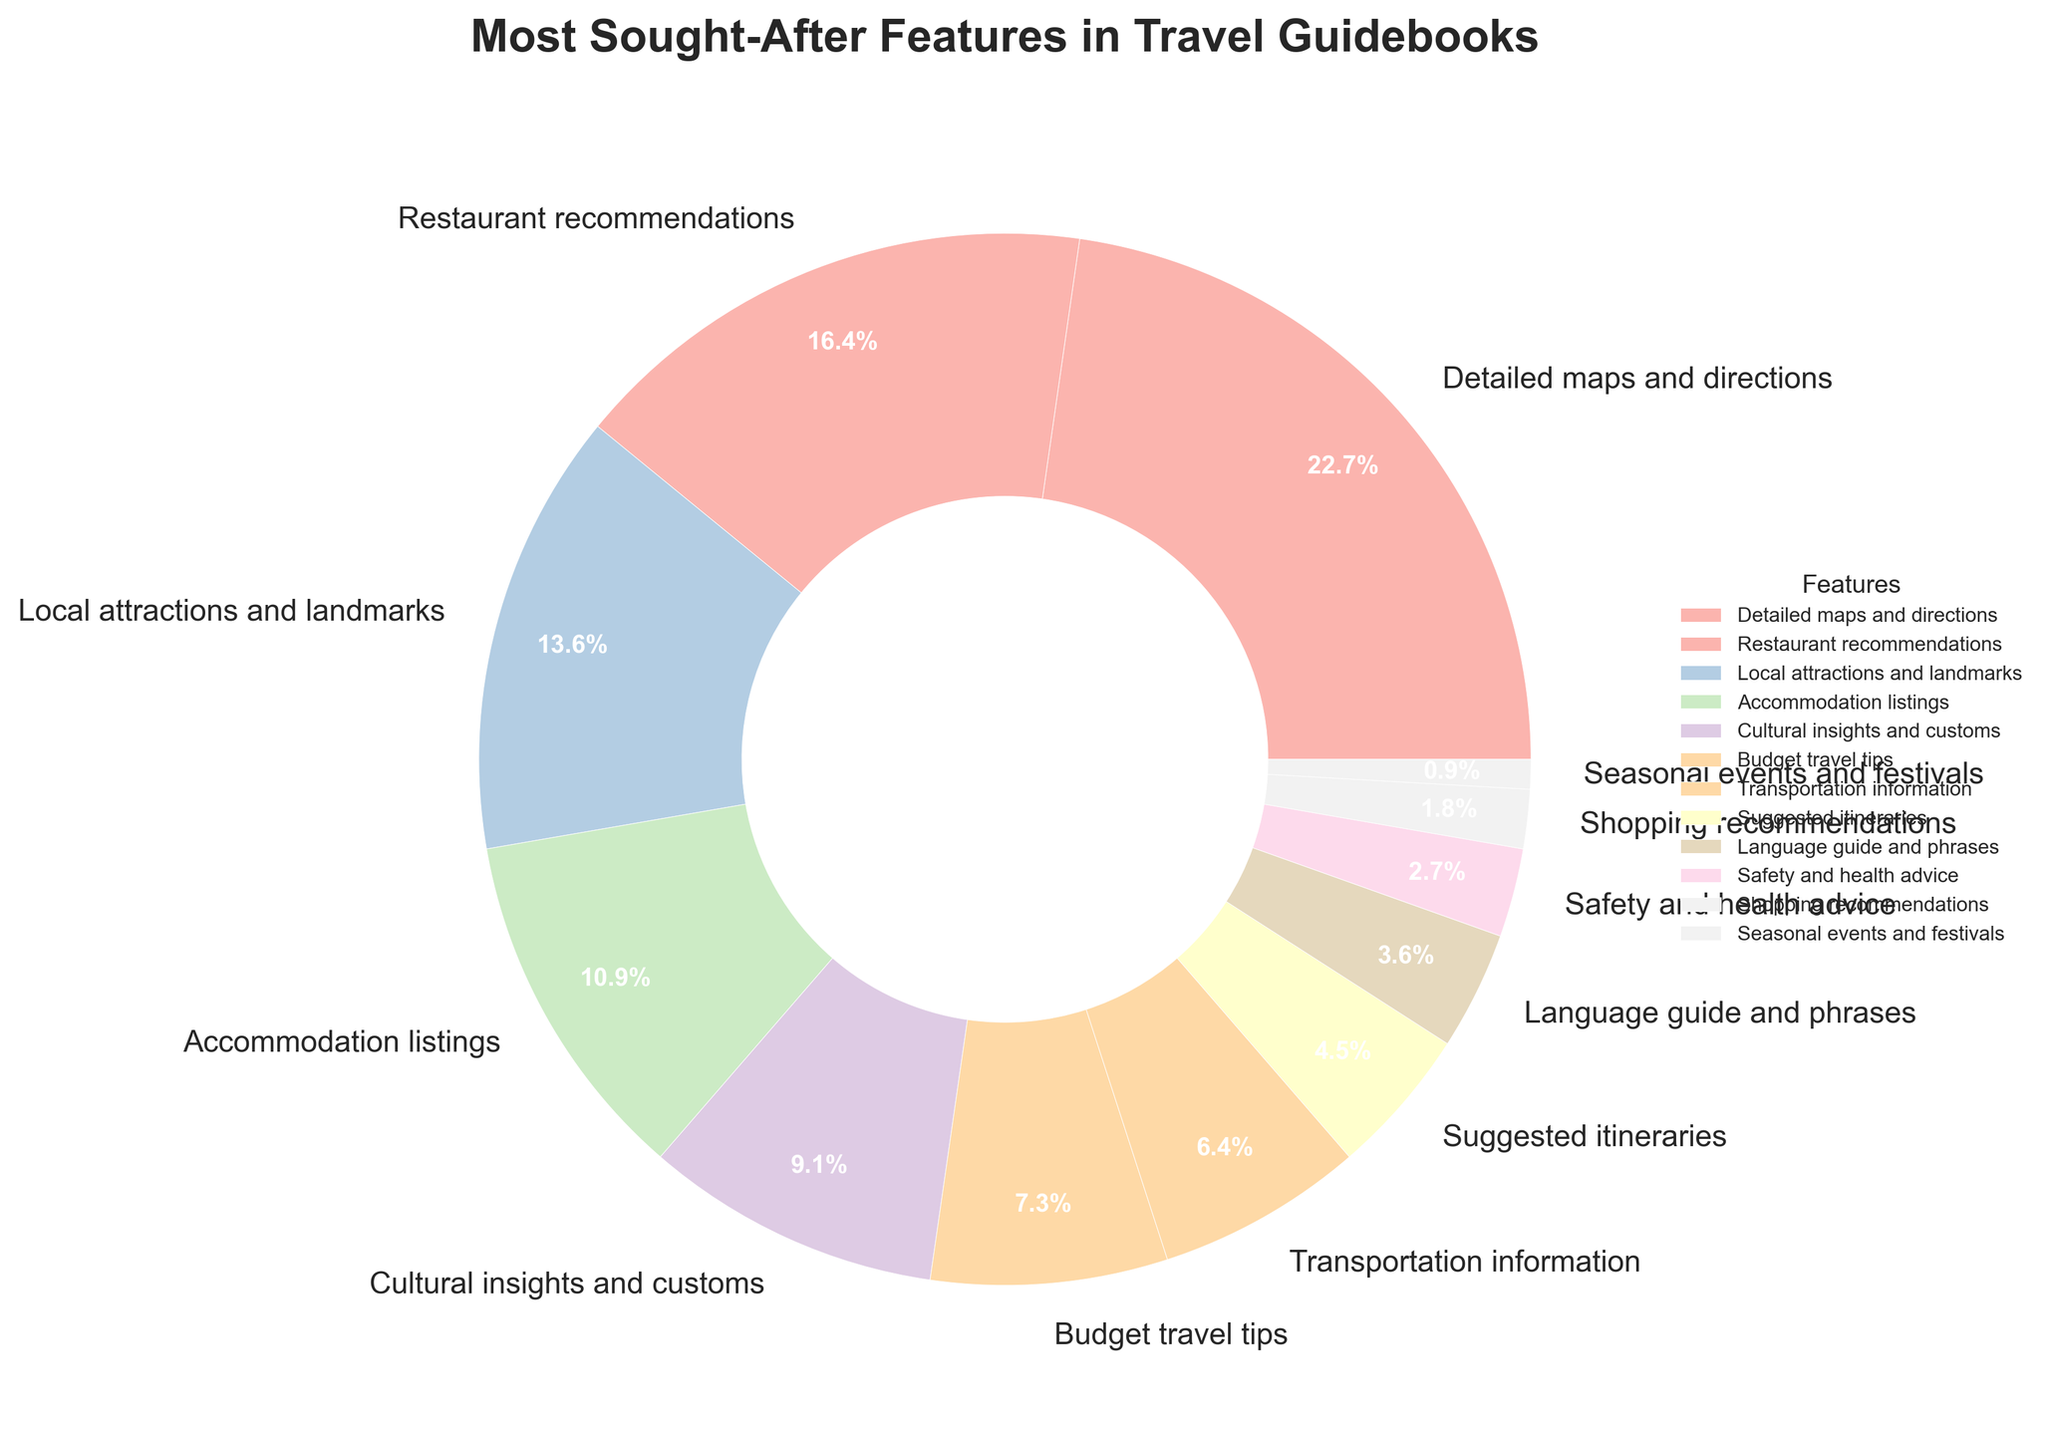What is the most sought-after feature in travel guidebooks? The most sought-after feature can be identified by looking at the segment with the largest percentage in the pie chart. The segment representing "Detailed maps and directions" occupies the largest portion, with a percentage of 25%.
Answer: Detailed maps and directions Which feature is least sought-after in travel guidebooks? The least sought-after feature can be identified by looking at the segment with the smallest percentage. The segment representing "Seasonal events and festivals" occupies the smallest portion, with a percentage of 1%.
Answer: Seasonal events and festivals What is the combined percentage of features related to food and accommodations? The related features are "Restaurant recommendations" and "Accommodation listings". Their percentages are 18% and 12%, respectively. Adding these percentages together gives 18% + 12% = 30%.
Answer: 30% Is the percentage of "Cultural insights and customs" greater or less than the percentage of "Budget travel tips"? The percentage for "Cultural insights and customs" is 10%, and for "Budget travel tips" it is 8%. Since 10% is greater than 8%, the percentage of "Cultural insights and customs" is greater.
Answer: Greater What is the percentage difference between "Transportation information" and "Suggested itineraries"? The percentage for "Transportation information" is 7%, and for "Suggested itineraries" it is 5%. The difference is calculated as 7% - 5% = 2%.
Answer: 2% Which features each have less than 5% share? We identify the segments with percentages less than 5%: "Language guide and phrases" (4%), "Safety and health advice" (3%), "Shopping recommendations" (2%), and "Seasonal events and festivals" (1%).
Answer: Language guide and phrases, Safety and health advice, Shopping recommendations, Seasonal events and festivals How do the combined segments for "Local attractions and landmarks" and "Cultural insights and customs" compare to "Detailed maps and directions"? The combined segments for "Local attractions and landmarks" and "Cultural insights and customs" are 15% + 10% = 25%. "Detailed maps and directions" also has 25%. Therefore, they are equal in percentage.
Answer: Equal Which feature is represented by a wedge with a noticeably lighter color compared to "Detailed maps and directions"? The feature "Language guide and phrases" (4%) is represented by a wedge noticeably lighter in color compared to the wedge for "Detailed maps and directions" (25%).
Answer: Language guide and phrases Arrange the features "Accommodation listings", "Safety and health advice", and "Shopping recommendations" in descending order based on their percentages. The percentages for the features are: "Accommodation listings" (12%), "Safety and health advice" (3%), and "Shopping recommendations" (2%). Arranging them in descending order gives: 12%, 3%, 2%.
Answer: Accommodation listings, Safety and health advice, Shopping recommendations What is the total percentage of features with percentages less than or equal to 5%? The features with percentages less than or equal to 5% are: "Suggested itineraries" (5%), "Language guide and phrases" (4%), "Safety and health advice" (3%), "Shopping recommendations" (2%), and "Seasonal events and festivals" (1%). Adding their percentages together gives: 5% + 4% + 3% + 2% + 1% = 15%.
Answer: 15% 